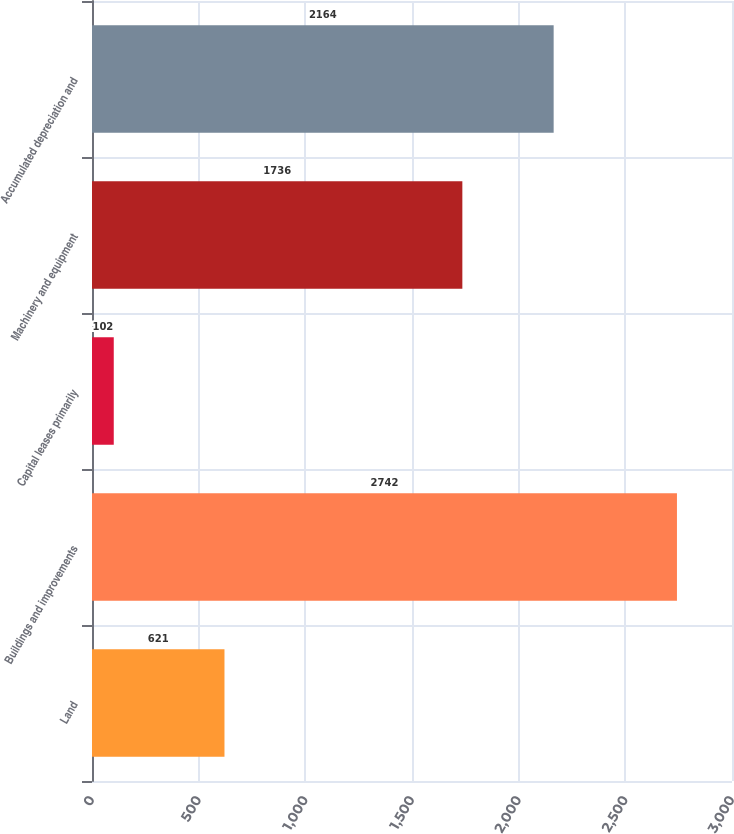Convert chart to OTSL. <chart><loc_0><loc_0><loc_500><loc_500><bar_chart><fcel>Land<fcel>Buildings and improvements<fcel>Capital leases primarily<fcel>Machinery and equipment<fcel>Accumulated depreciation and<nl><fcel>621<fcel>2742<fcel>102<fcel>1736<fcel>2164<nl></chart> 